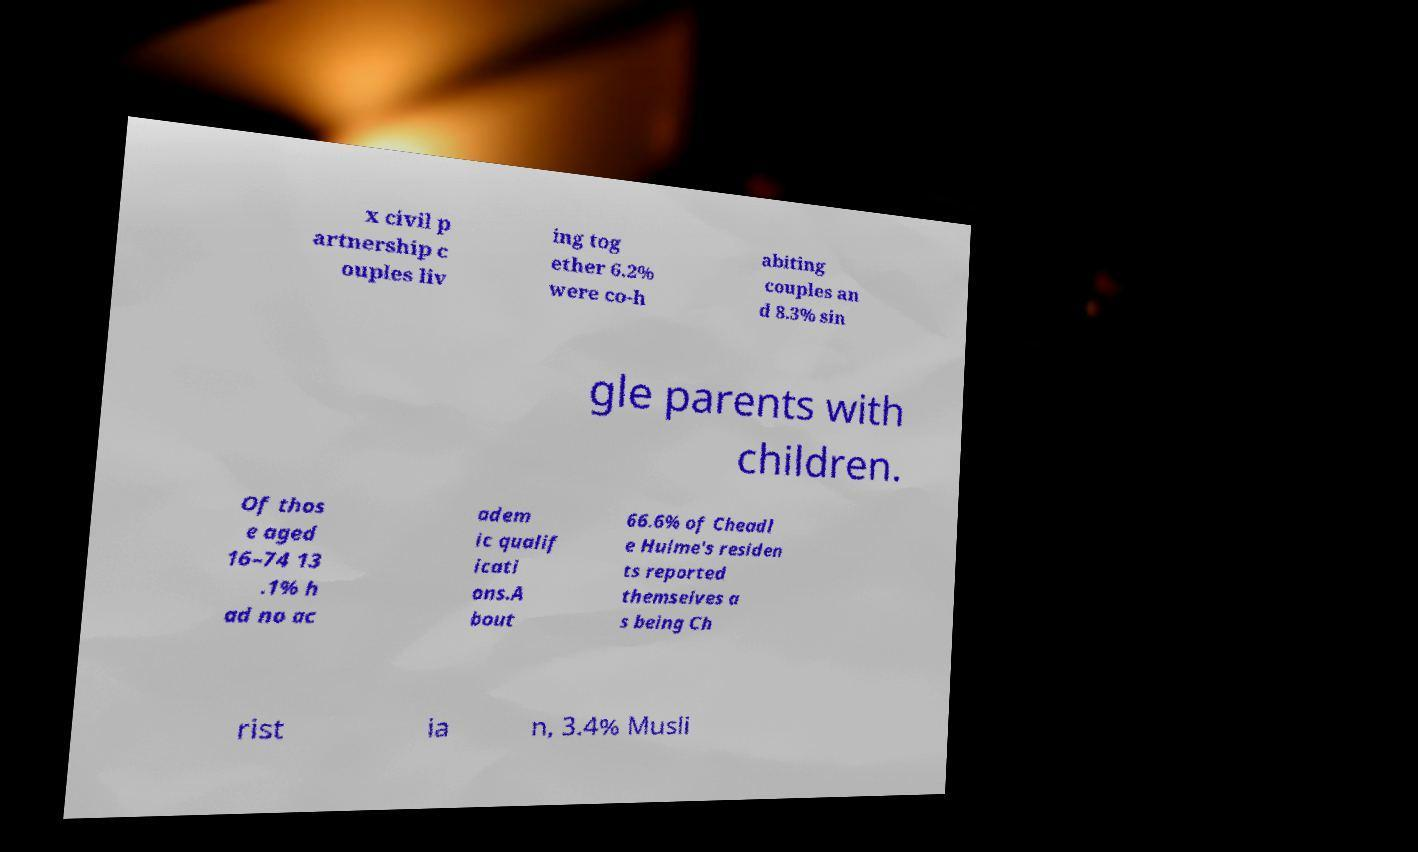For documentation purposes, I need the text within this image transcribed. Could you provide that? x civil p artnership c ouples liv ing tog ether 6.2% were co-h abiting couples an d 8.3% sin gle parents with children. Of thos e aged 16–74 13 .1% h ad no ac adem ic qualif icati ons.A bout 66.6% of Cheadl e Hulme's residen ts reported themselves a s being Ch rist ia n, 3.4% Musli 